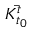<formula> <loc_0><loc_0><loc_500><loc_500>\ B a r { { K } _ { t _ { 0 } } ^ { t } }</formula> 